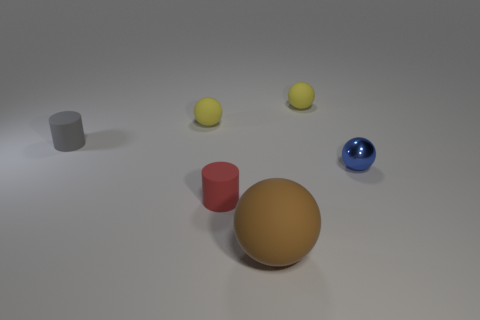What can we infer about the lighting in this scene? The lighting in this scene seems to come from above as indicated by the shadows directly under the objects. The soft shadows suggest a diffuse light source, potentially a large overhead softbox or a cloudy sky that scatters the light, reducing harshness and providing an even illumination across the scene. How does the lighting affect the appearance of the objects? The diffuse lighting softens the appearance of the materials, highlighting their textures and colors without creating harsh glares or overly deep shadows. This results in a more true-to-life representation of each object's color and material properties, making them appear as they would under natural, ambient light conditions. 